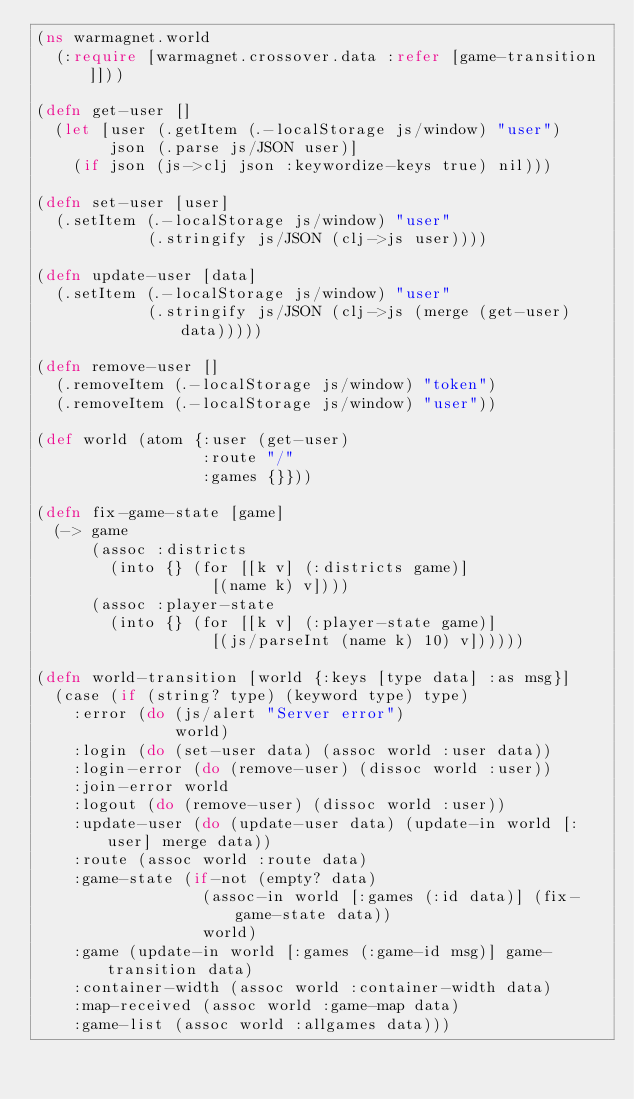Convert code to text. <code><loc_0><loc_0><loc_500><loc_500><_Clojure_>(ns warmagnet.world
  (:require [warmagnet.crossover.data :refer [game-transition]]))

(defn get-user []
  (let [user (.getItem (.-localStorage js/window) "user")
        json (.parse js/JSON user)]
    (if json (js->clj json :keywordize-keys true) nil)))

(defn set-user [user]
  (.setItem (.-localStorage js/window) "user"
            (.stringify js/JSON (clj->js user))))

(defn update-user [data]
  (.setItem (.-localStorage js/window) "user"
            (.stringify js/JSON (clj->js (merge (get-user) data)))))

(defn remove-user []
  (.removeItem (.-localStorage js/window) "token")
  (.removeItem (.-localStorage js/window) "user"))

(def world (atom {:user (get-user)
                  :route "/"
                  :games {}}))

(defn fix-game-state [game]
  (-> game
      (assoc :districts
        (into {} (for [[k v] (:districts game)]
                   [(name k) v])))
      (assoc :player-state
        (into {} (for [[k v] (:player-state game)]
                   [(js/parseInt (name k) 10) v])))))

(defn world-transition [world {:keys [type data] :as msg}]
  (case (if (string? type) (keyword type) type)
    :error (do (js/alert "Server error")
               world)
    :login (do (set-user data) (assoc world :user data))
    :login-error (do (remove-user) (dissoc world :user))
    :join-error world
    :logout (do (remove-user) (dissoc world :user))
    :update-user (do (update-user data) (update-in world [:user] merge data))
    :route (assoc world :route data)
    :game-state (if-not (empty? data)
                  (assoc-in world [:games (:id data)] (fix-game-state data))
                  world)
    :game (update-in world [:games (:game-id msg)] game-transition data)
    :container-width (assoc world :container-width data)
    :map-received (assoc world :game-map data)
    :game-list (assoc world :allgames data)))
</code> 